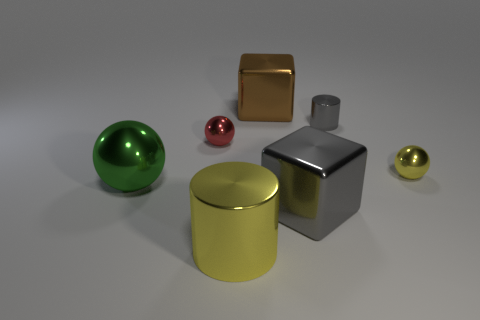There is a object that is the same color as the large shiny cylinder; what size is it?
Provide a succinct answer. Small. The small red metallic object has what shape?
Offer a very short reply. Sphere. Is there a sphere of the same color as the big metal cylinder?
Your response must be concise. Yes. Is the number of large gray blocks that are on the right side of the large green sphere greater than the number of big brown rubber balls?
Give a very brief answer. Yes. Does the big green metal object have the same shape as the tiny shiny object on the left side of the small gray object?
Keep it short and to the point. Yes. Are there any tiny yellow metal balls?
Your answer should be very brief. Yes. What number of tiny things are either purple matte balls or brown metallic blocks?
Provide a succinct answer. 0. Are there more metal cylinders that are to the left of the gray metal cylinder than metal cylinders to the right of the tiny yellow shiny thing?
Keep it short and to the point. Yes. Are the large yellow thing and the large gray cube to the right of the large yellow metal cylinder made of the same material?
Your response must be concise. Yes. The large cylinder has what color?
Your answer should be compact. Yellow. 